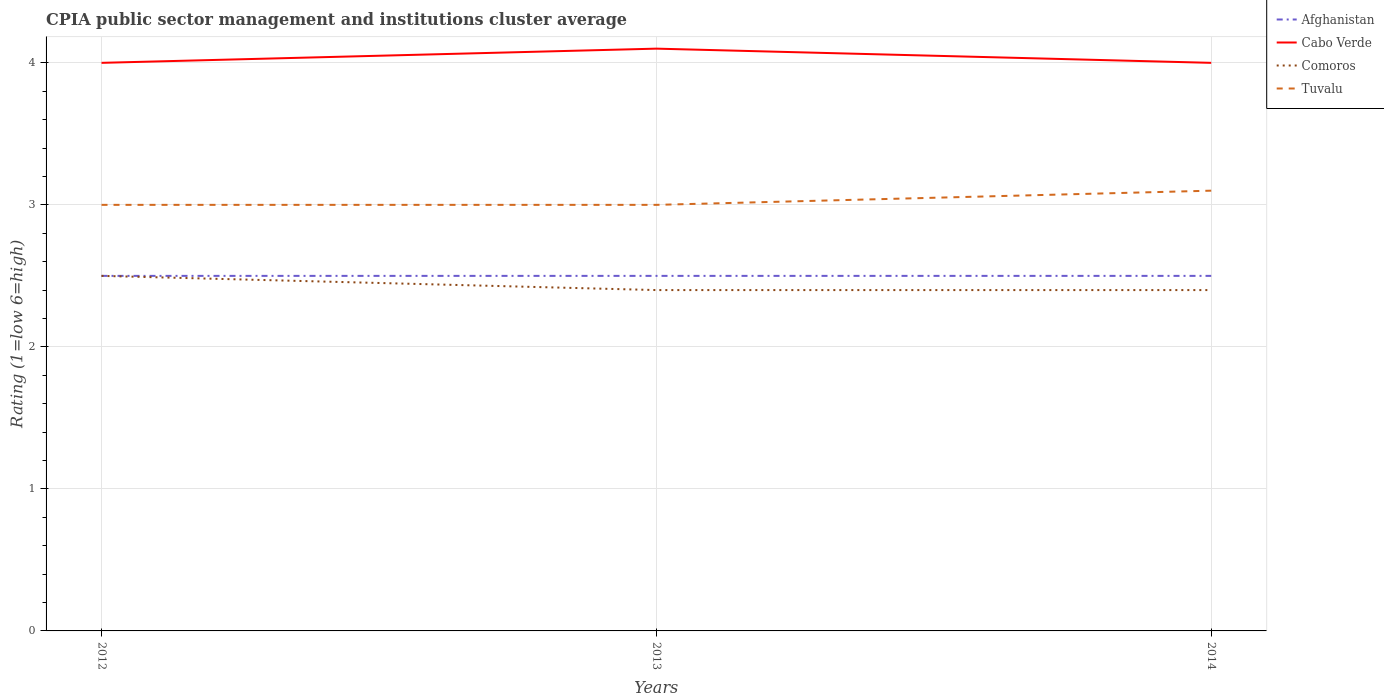How many different coloured lines are there?
Your response must be concise. 4. Does the line corresponding to Afghanistan intersect with the line corresponding to Comoros?
Ensure brevity in your answer.  Yes. In which year was the CPIA rating in Comoros maximum?
Your response must be concise. 2013. What is the total CPIA rating in Tuvalu in the graph?
Provide a succinct answer. -0.1. What is the difference between the highest and the second highest CPIA rating in Tuvalu?
Give a very brief answer. 0.1. Is the CPIA rating in Comoros strictly greater than the CPIA rating in Cabo Verde over the years?
Offer a terse response. Yes. How many lines are there?
Offer a terse response. 4. Are the values on the major ticks of Y-axis written in scientific E-notation?
Give a very brief answer. No. Does the graph contain any zero values?
Ensure brevity in your answer.  No. Does the graph contain grids?
Ensure brevity in your answer.  Yes. What is the title of the graph?
Your answer should be compact. CPIA public sector management and institutions cluster average. Does "Central African Republic" appear as one of the legend labels in the graph?
Offer a very short reply. No. What is the label or title of the X-axis?
Ensure brevity in your answer.  Years. What is the Rating (1=low 6=high) of Afghanistan in 2012?
Keep it short and to the point. 2.5. What is the Rating (1=low 6=high) in Cabo Verde in 2012?
Keep it short and to the point. 4. What is the Rating (1=low 6=high) of Comoros in 2012?
Provide a succinct answer. 2.5. What is the Rating (1=low 6=high) of Tuvalu in 2012?
Ensure brevity in your answer.  3. What is the Rating (1=low 6=high) of Comoros in 2013?
Your answer should be very brief. 2.4. What is the Rating (1=low 6=high) of Tuvalu in 2013?
Give a very brief answer. 3. Across all years, what is the maximum Rating (1=low 6=high) in Afghanistan?
Offer a very short reply. 2.5. Across all years, what is the maximum Rating (1=low 6=high) of Tuvalu?
Your response must be concise. 3.1. Across all years, what is the minimum Rating (1=low 6=high) of Cabo Verde?
Your answer should be very brief. 4. Across all years, what is the minimum Rating (1=low 6=high) in Comoros?
Your answer should be very brief. 2.4. What is the total Rating (1=low 6=high) of Afghanistan in the graph?
Keep it short and to the point. 7.5. What is the difference between the Rating (1=low 6=high) of Afghanistan in 2012 and that in 2013?
Ensure brevity in your answer.  0. What is the difference between the Rating (1=low 6=high) of Comoros in 2012 and that in 2013?
Make the answer very short. 0.1. What is the difference between the Rating (1=low 6=high) in Tuvalu in 2012 and that in 2013?
Keep it short and to the point. 0. What is the difference between the Rating (1=low 6=high) of Afghanistan in 2012 and that in 2014?
Ensure brevity in your answer.  0. What is the difference between the Rating (1=low 6=high) in Cabo Verde in 2012 and that in 2014?
Provide a succinct answer. 0. What is the difference between the Rating (1=low 6=high) of Tuvalu in 2012 and that in 2014?
Your answer should be very brief. -0.1. What is the difference between the Rating (1=low 6=high) of Afghanistan in 2013 and that in 2014?
Offer a very short reply. 0. What is the difference between the Rating (1=low 6=high) in Tuvalu in 2013 and that in 2014?
Your answer should be very brief. -0.1. What is the difference between the Rating (1=low 6=high) in Afghanistan in 2012 and the Rating (1=low 6=high) in Cabo Verde in 2013?
Keep it short and to the point. -1.6. What is the difference between the Rating (1=low 6=high) in Afghanistan in 2012 and the Rating (1=low 6=high) in Tuvalu in 2013?
Your response must be concise. -0.5. What is the difference between the Rating (1=low 6=high) in Cabo Verde in 2012 and the Rating (1=low 6=high) in Comoros in 2013?
Provide a succinct answer. 1.6. What is the difference between the Rating (1=low 6=high) in Afghanistan in 2012 and the Rating (1=low 6=high) in Tuvalu in 2014?
Keep it short and to the point. -0.6. What is the difference between the Rating (1=low 6=high) of Cabo Verde in 2012 and the Rating (1=low 6=high) of Comoros in 2014?
Your response must be concise. 1.6. What is the difference between the Rating (1=low 6=high) of Comoros in 2012 and the Rating (1=low 6=high) of Tuvalu in 2014?
Ensure brevity in your answer.  -0.6. What is the difference between the Rating (1=low 6=high) of Afghanistan in 2013 and the Rating (1=low 6=high) of Cabo Verde in 2014?
Provide a succinct answer. -1.5. What is the difference between the Rating (1=low 6=high) in Cabo Verde in 2013 and the Rating (1=low 6=high) in Tuvalu in 2014?
Offer a very short reply. 1. What is the difference between the Rating (1=low 6=high) in Comoros in 2013 and the Rating (1=low 6=high) in Tuvalu in 2014?
Keep it short and to the point. -0.7. What is the average Rating (1=low 6=high) of Afghanistan per year?
Give a very brief answer. 2.5. What is the average Rating (1=low 6=high) of Cabo Verde per year?
Your response must be concise. 4.03. What is the average Rating (1=low 6=high) in Comoros per year?
Provide a succinct answer. 2.43. What is the average Rating (1=low 6=high) in Tuvalu per year?
Ensure brevity in your answer.  3.03. In the year 2012, what is the difference between the Rating (1=low 6=high) in Comoros and Rating (1=low 6=high) in Tuvalu?
Ensure brevity in your answer.  -0.5. In the year 2013, what is the difference between the Rating (1=low 6=high) of Afghanistan and Rating (1=low 6=high) of Cabo Verde?
Ensure brevity in your answer.  -1.6. In the year 2013, what is the difference between the Rating (1=low 6=high) in Cabo Verde and Rating (1=low 6=high) in Comoros?
Ensure brevity in your answer.  1.7. In the year 2013, what is the difference between the Rating (1=low 6=high) of Cabo Verde and Rating (1=low 6=high) of Tuvalu?
Provide a short and direct response. 1.1. In the year 2014, what is the difference between the Rating (1=low 6=high) in Afghanistan and Rating (1=low 6=high) in Cabo Verde?
Your response must be concise. -1.5. In the year 2014, what is the difference between the Rating (1=low 6=high) in Afghanistan and Rating (1=low 6=high) in Tuvalu?
Offer a very short reply. -0.6. What is the ratio of the Rating (1=low 6=high) of Cabo Verde in 2012 to that in 2013?
Make the answer very short. 0.98. What is the ratio of the Rating (1=low 6=high) of Comoros in 2012 to that in 2013?
Make the answer very short. 1.04. What is the ratio of the Rating (1=low 6=high) in Afghanistan in 2012 to that in 2014?
Ensure brevity in your answer.  1. What is the ratio of the Rating (1=low 6=high) of Comoros in 2012 to that in 2014?
Keep it short and to the point. 1.04. What is the ratio of the Rating (1=low 6=high) in Afghanistan in 2013 to that in 2014?
Your answer should be compact. 1. What is the ratio of the Rating (1=low 6=high) in Cabo Verde in 2013 to that in 2014?
Offer a terse response. 1.02. What is the ratio of the Rating (1=low 6=high) of Comoros in 2013 to that in 2014?
Provide a succinct answer. 1. What is the ratio of the Rating (1=low 6=high) in Tuvalu in 2013 to that in 2014?
Provide a short and direct response. 0.97. What is the difference between the highest and the second highest Rating (1=low 6=high) of Cabo Verde?
Your response must be concise. 0.1. What is the difference between the highest and the second highest Rating (1=low 6=high) of Comoros?
Your answer should be compact. 0.1. What is the difference between the highest and the second highest Rating (1=low 6=high) in Tuvalu?
Provide a succinct answer. 0.1. What is the difference between the highest and the lowest Rating (1=low 6=high) of Afghanistan?
Make the answer very short. 0. What is the difference between the highest and the lowest Rating (1=low 6=high) of Cabo Verde?
Offer a terse response. 0.1. 